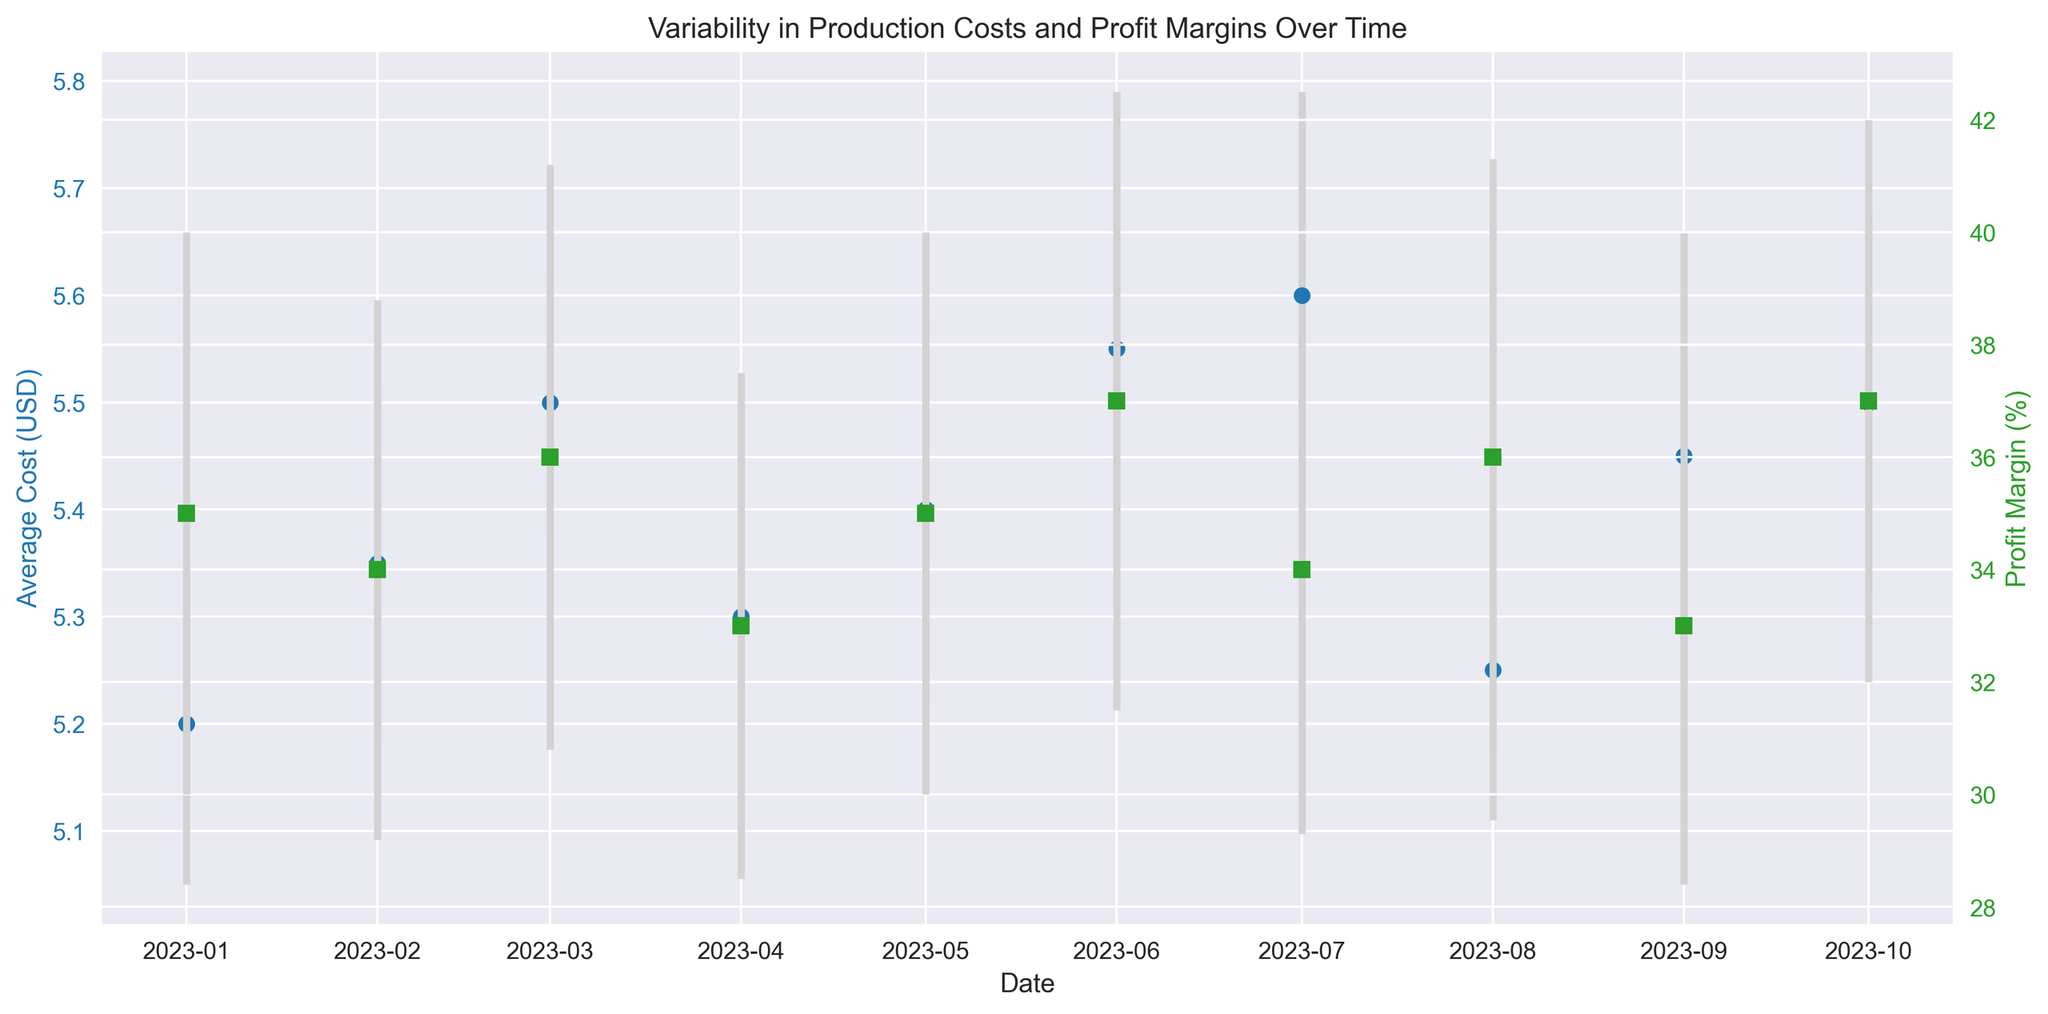What is the date with the highest average cost? Looking at the blue points on the graph, the highest vertical position of the blue points indicates the highest average cost. The date corresponding to this is around June or July. Checking the figure more precisely, the highest average cost is in July.
Answer: 2023-07-01 Which date has the lowest profit margin? The green points representing profit margins show their lowest point visually around April or September. Checking the figure more precisely, the lowest profit margin is in April and September, both at 33%.
Answer: 2023-04-01 and 2023-09-01 What is the range of average cost values observed over the period? The highest average cost value is around $5.60 (in July), and the lowest is around $5.20 (in January). The range is their difference: $5.60 - $5.20.
Answer: $0.40 Between which months did the average cost see the most significant drop? To find the most significant drop, examine consecutive points for the largest vertical downward shift in the blue points with their error bars. The most significant drop occurs between June and July.
Answer: 2023-06-01 to 2023-07-01 How consistent is the profit margin over the observed period? The variance in green points and their error bars indicates the consistency of the profit margin. The profit margin fluctuates between roughly 33% and 37%, with a few ups and downs but generally staying within this range.
Answer: Moderately consistent Which date has the highest standard deviation in average costs? The length of the error bars for blue points indicates standard deviation. The longest error bar visually appears around September. Checking the figure precisely, September has the highest standard deviation of $0.21.
Answer: 2023-09-01 How do fluctuations in average cost correlate with profit margin changes? By observing the trends of both blue and green points, if the blue points (costs) go up or down, we see if the green points (profit margins) follow or oppose. Generally, when average costs go up, profit margins tend to decline or stay stable. For instance, from January to February, cost increases and margin decrease.
Answer: Inversely correlated What is the average profit margin over the entire period? Sum all profit margin percentages and divide by the number of observations: (35 + 34 + 36 + 33 + 35 + 37 + 34 + 36 + 33 + 37)/ 10 = 35
Answer: 35% On which date does the profit margin have the smallest error margin? The shortest error bars for green points indicate error margin in profit. The shortest green error bars visually appear around April. Checking the figure more precisely, April has the smallest error margin at 4.5%.
Answer: 2023-04-01 